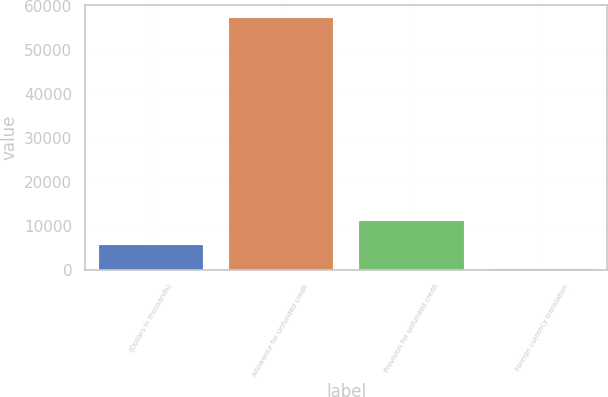<chart> <loc_0><loc_0><loc_500><loc_500><bar_chart><fcel>(Dollars in thousands)<fcel>Allowance for unfunded credit<fcel>Provision for unfunded credit<fcel>Foreign currency translation<nl><fcel>5666.8<fcel>57271.8<fcel>11168.6<fcel>165<nl></chart> 